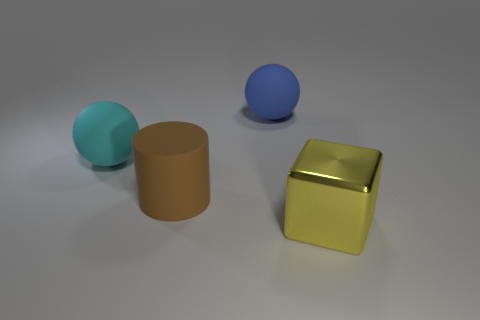Are there any other things that have the same shape as the large brown matte object?
Your answer should be very brief. No. Are there more large cylinders than purple spheres?
Keep it short and to the point. Yes. What number of big things are both on the right side of the large brown matte cylinder and to the left of the big yellow shiny block?
Your answer should be compact. 1. There is a ball that is in front of the blue rubber object; what number of shiny things are on the left side of it?
Offer a terse response. 0. There is a cylinder that is in front of the blue matte sphere; does it have the same size as the cyan ball that is left of the big brown thing?
Offer a very short reply. Yes. How many large brown rubber objects are there?
Keep it short and to the point. 1. How many blue balls are the same material as the yellow thing?
Provide a short and direct response. 0. Are there an equal number of metal blocks that are to the left of the big cyan rubber object and big green shiny blocks?
Your response must be concise. Yes. How many other things are the same size as the yellow object?
Your answer should be compact. 3. What number of other objects are there of the same color as the shiny thing?
Offer a very short reply. 0. 